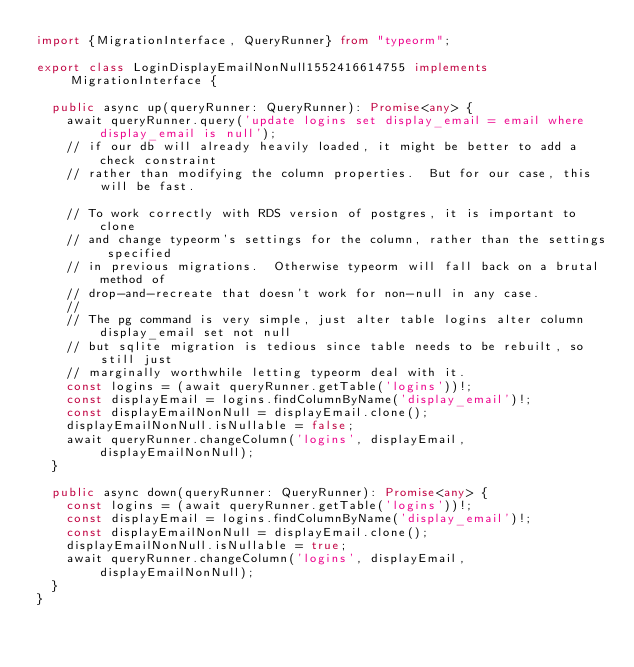Convert code to text. <code><loc_0><loc_0><loc_500><loc_500><_TypeScript_>import {MigrationInterface, QueryRunner} from "typeorm";

export class LoginDisplayEmailNonNull1552416614755 implements MigrationInterface {

  public async up(queryRunner: QueryRunner): Promise<any> {
    await queryRunner.query('update logins set display_email = email where display_email is null');
    // if our db will already heavily loaded, it might be better to add a check constraint
    // rather than modifying the column properties.  But for our case, this will be fast.

    // To work correctly with RDS version of postgres, it is important to clone
    // and change typeorm's settings for the column, rather than the settings specified
    // in previous migrations.  Otherwise typeorm will fall back on a brutal method of
    // drop-and-recreate that doesn't work for non-null in any case.
    //
    // The pg command is very simple, just alter table logins alter column display_email set not null
    // but sqlite migration is tedious since table needs to be rebuilt, so still just
    // marginally worthwhile letting typeorm deal with it.
    const logins = (await queryRunner.getTable('logins'))!;
    const displayEmail = logins.findColumnByName('display_email')!;
    const displayEmailNonNull = displayEmail.clone();
    displayEmailNonNull.isNullable = false;
    await queryRunner.changeColumn('logins', displayEmail, displayEmailNonNull);
  }

  public async down(queryRunner: QueryRunner): Promise<any> {
    const logins = (await queryRunner.getTable('logins'))!;
    const displayEmail = logins.findColumnByName('display_email')!;
    const displayEmailNonNull = displayEmail.clone();
    displayEmailNonNull.isNullable = true;
    await queryRunner.changeColumn('logins', displayEmail, displayEmailNonNull);
  }
}
</code> 